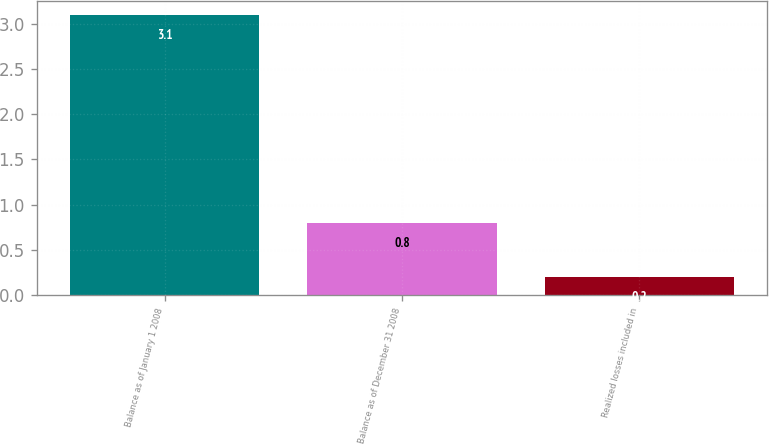Convert chart. <chart><loc_0><loc_0><loc_500><loc_500><bar_chart><fcel>Balance as of January 1 2008<fcel>Balance as of December 31 2008<fcel>Realized losses included in<nl><fcel>3.1<fcel>0.8<fcel>0.2<nl></chart> 